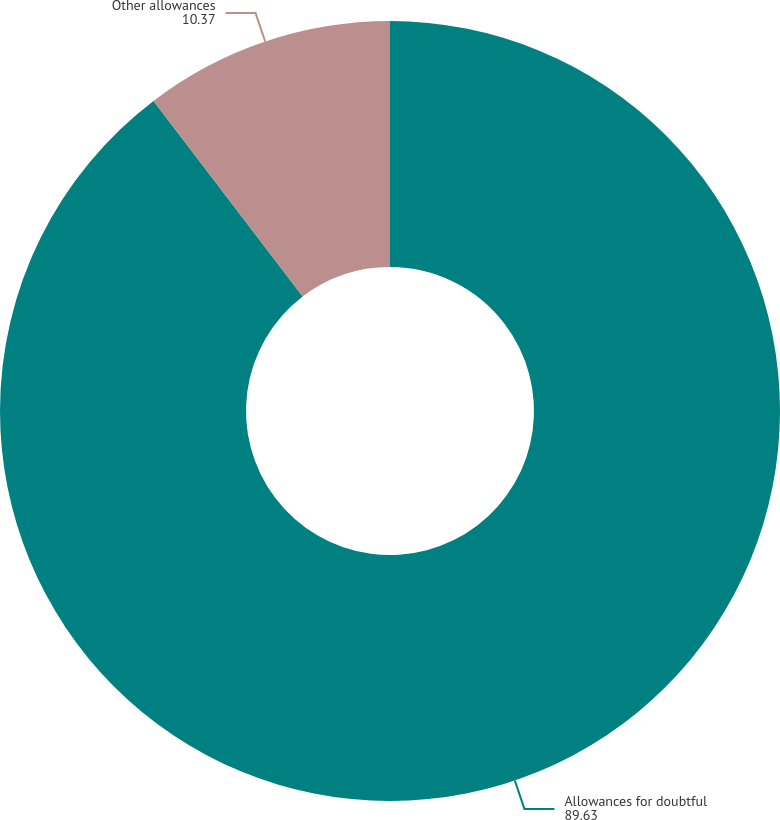Convert chart. <chart><loc_0><loc_0><loc_500><loc_500><pie_chart><fcel>Allowances for doubtful<fcel>Other allowances<nl><fcel>89.63%<fcel>10.37%<nl></chart> 